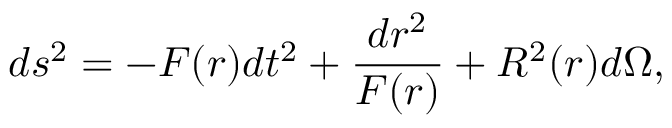Convert formula to latex. <formula><loc_0><loc_0><loc_500><loc_500>d s ^ { 2 } = - F ( r ) d t ^ { 2 } + { \frac { d r ^ { 2 } } { F ( r ) } } + R ^ { 2 } ( r ) d \Omega ,</formula> 